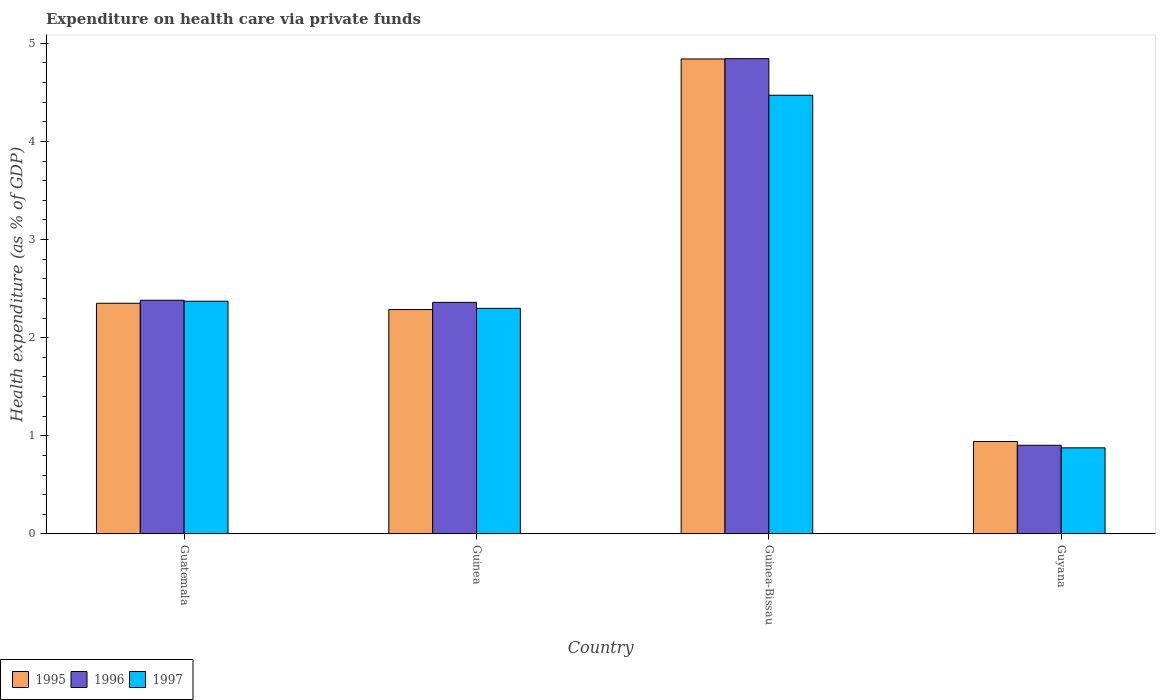How many groups of bars are there?
Your response must be concise. 4. What is the label of the 1st group of bars from the left?
Ensure brevity in your answer.  Guatemala. What is the expenditure made on health care in 1996 in Guatemala?
Your answer should be compact. 2.38. Across all countries, what is the maximum expenditure made on health care in 1995?
Your response must be concise. 4.84. Across all countries, what is the minimum expenditure made on health care in 1996?
Your answer should be compact. 0.9. In which country was the expenditure made on health care in 1995 maximum?
Your answer should be very brief. Guinea-Bissau. In which country was the expenditure made on health care in 1995 minimum?
Keep it short and to the point. Guyana. What is the total expenditure made on health care in 1995 in the graph?
Your response must be concise. 10.42. What is the difference between the expenditure made on health care in 1995 in Guatemala and that in Guinea-Bissau?
Your answer should be compact. -2.49. What is the difference between the expenditure made on health care in 1995 in Guatemala and the expenditure made on health care in 1996 in Guinea-Bissau?
Provide a short and direct response. -2.49. What is the average expenditure made on health care in 1995 per country?
Offer a very short reply. 2.61. What is the difference between the expenditure made on health care of/in 1995 and expenditure made on health care of/in 1997 in Guatemala?
Keep it short and to the point. -0.02. What is the ratio of the expenditure made on health care in 1996 in Guinea to that in Guinea-Bissau?
Offer a terse response. 0.49. Is the expenditure made on health care in 1996 in Guinea less than that in Guyana?
Keep it short and to the point. No. What is the difference between the highest and the second highest expenditure made on health care in 1995?
Offer a very short reply. 0.06. What is the difference between the highest and the lowest expenditure made on health care in 1997?
Offer a terse response. 3.59. In how many countries, is the expenditure made on health care in 1996 greater than the average expenditure made on health care in 1996 taken over all countries?
Provide a succinct answer. 1. What does the 1st bar from the left in Guinea represents?
Your response must be concise. 1995. What does the 2nd bar from the right in Guinea-Bissau represents?
Offer a terse response. 1996. Is it the case that in every country, the sum of the expenditure made on health care in 1997 and expenditure made on health care in 1995 is greater than the expenditure made on health care in 1996?
Make the answer very short. Yes. How many bars are there?
Ensure brevity in your answer.  12. How many countries are there in the graph?
Keep it short and to the point. 4. What is the difference between two consecutive major ticks on the Y-axis?
Keep it short and to the point. 1. Does the graph contain any zero values?
Your answer should be compact. No. Where does the legend appear in the graph?
Keep it short and to the point. Bottom left. How many legend labels are there?
Keep it short and to the point. 3. What is the title of the graph?
Offer a very short reply. Expenditure on health care via private funds. Does "1974" appear as one of the legend labels in the graph?
Keep it short and to the point. No. What is the label or title of the X-axis?
Give a very brief answer. Country. What is the label or title of the Y-axis?
Offer a very short reply. Health expenditure (as % of GDP). What is the Health expenditure (as % of GDP) in 1995 in Guatemala?
Ensure brevity in your answer.  2.35. What is the Health expenditure (as % of GDP) in 1996 in Guatemala?
Ensure brevity in your answer.  2.38. What is the Health expenditure (as % of GDP) of 1997 in Guatemala?
Provide a succinct answer. 2.37. What is the Health expenditure (as % of GDP) of 1995 in Guinea?
Keep it short and to the point. 2.29. What is the Health expenditure (as % of GDP) of 1996 in Guinea?
Your response must be concise. 2.36. What is the Health expenditure (as % of GDP) of 1997 in Guinea?
Provide a short and direct response. 2.3. What is the Health expenditure (as % of GDP) of 1995 in Guinea-Bissau?
Ensure brevity in your answer.  4.84. What is the Health expenditure (as % of GDP) in 1996 in Guinea-Bissau?
Your answer should be very brief. 4.84. What is the Health expenditure (as % of GDP) in 1997 in Guinea-Bissau?
Your answer should be compact. 4.47. What is the Health expenditure (as % of GDP) in 1995 in Guyana?
Offer a very short reply. 0.94. What is the Health expenditure (as % of GDP) in 1996 in Guyana?
Your response must be concise. 0.9. What is the Health expenditure (as % of GDP) in 1997 in Guyana?
Offer a terse response. 0.88. Across all countries, what is the maximum Health expenditure (as % of GDP) of 1995?
Ensure brevity in your answer.  4.84. Across all countries, what is the maximum Health expenditure (as % of GDP) in 1996?
Provide a succinct answer. 4.84. Across all countries, what is the maximum Health expenditure (as % of GDP) of 1997?
Your response must be concise. 4.47. Across all countries, what is the minimum Health expenditure (as % of GDP) of 1995?
Make the answer very short. 0.94. Across all countries, what is the minimum Health expenditure (as % of GDP) in 1996?
Your answer should be very brief. 0.9. Across all countries, what is the minimum Health expenditure (as % of GDP) of 1997?
Provide a short and direct response. 0.88. What is the total Health expenditure (as % of GDP) in 1995 in the graph?
Your answer should be very brief. 10.42. What is the total Health expenditure (as % of GDP) in 1996 in the graph?
Provide a short and direct response. 10.49. What is the total Health expenditure (as % of GDP) in 1997 in the graph?
Give a very brief answer. 10.02. What is the difference between the Health expenditure (as % of GDP) of 1995 in Guatemala and that in Guinea?
Provide a succinct answer. 0.06. What is the difference between the Health expenditure (as % of GDP) of 1996 in Guatemala and that in Guinea?
Your response must be concise. 0.02. What is the difference between the Health expenditure (as % of GDP) in 1997 in Guatemala and that in Guinea?
Make the answer very short. 0.07. What is the difference between the Health expenditure (as % of GDP) in 1995 in Guatemala and that in Guinea-Bissau?
Make the answer very short. -2.49. What is the difference between the Health expenditure (as % of GDP) in 1996 in Guatemala and that in Guinea-Bissau?
Make the answer very short. -2.46. What is the difference between the Health expenditure (as % of GDP) in 1997 in Guatemala and that in Guinea-Bissau?
Offer a very short reply. -2.1. What is the difference between the Health expenditure (as % of GDP) of 1995 in Guatemala and that in Guyana?
Ensure brevity in your answer.  1.41. What is the difference between the Health expenditure (as % of GDP) of 1996 in Guatemala and that in Guyana?
Give a very brief answer. 1.48. What is the difference between the Health expenditure (as % of GDP) of 1997 in Guatemala and that in Guyana?
Keep it short and to the point. 1.49. What is the difference between the Health expenditure (as % of GDP) in 1995 in Guinea and that in Guinea-Bissau?
Ensure brevity in your answer.  -2.55. What is the difference between the Health expenditure (as % of GDP) in 1996 in Guinea and that in Guinea-Bissau?
Give a very brief answer. -2.48. What is the difference between the Health expenditure (as % of GDP) of 1997 in Guinea and that in Guinea-Bissau?
Give a very brief answer. -2.17. What is the difference between the Health expenditure (as % of GDP) of 1995 in Guinea and that in Guyana?
Give a very brief answer. 1.34. What is the difference between the Health expenditure (as % of GDP) in 1996 in Guinea and that in Guyana?
Ensure brevity in your answer.  1.46. What is the difference between the Health expenditure (as % of GDP) in 1997 in Guinea and that in Guyana?
Ensure brevity in your answer.  1.42. What is the difference between the Health expenditure (as % of GDP) in 1995 in Guinea-Bissau and that in Guyana?
Ensure brevity in your answer.  3.9. What is the difference between the Health expenditure (as % of GDP) in 1996 in Guinea-Bissau and that in Guyana?
Make the answer very short. 3.94. What is the difference between the Health expenditure (as % of GDP) of 1997 in Guinea-Bissau and that in Guyana?
Keep it short and to the point. 3.59. What is the difference between the Health expenditure (as % of GDP) in 1995 in Guatemala and the Health expenditure (as % of GDP) in 1996 in Guinea?
Your answer should be very brief. -0.01. What is the difference between the Health expenditure (as % of GDP) of 1995 in Guatemala and the Health expenditure (as % of GDP) of 1997 in Guinea?
Your answer should be compact. 0.05. What is the difference between the Health expenditure (as % of GDP) of 1996 in Guatemala and the Health expenditure (as % of GDP) of 1997 in Guinea?
Your response must be concise. 0.08. What is the difference between the Health expenditure (as % of GDP) in 1995 in Guatemala and the Health expenditure (as % of GDP) in 1996 in Guinea-Bissau?
Provide a short and direct response. -2.49. What is the difference between the Health expenditure (as % of GDP) of 1995 in Guatemala and the Health expenditure (as % of GDP) of 1997 in Guinea-Bissau?
Your answer should be compact. -2.12. What is the difference between the Health expenditure (as % of GDP) of 1996 in Guatemala and the Health expenditure (as % of GDP) of 1997 in Guinea-Bissau?
Give a very brief answer. -2.09. What is the difference between the Health expenditure (as % of GDP) of 1995 in Guatemala and the Health expenditure (as % of GDP) of 1996 in Guyana?
Your response must be concise. 1.45. What is the difference between the Health expenditure (as % of GDP) in 1995 in Guatemala and the Health expenditure (as % of GDP) in 1997 in Guyana?
Keep it short and to the point. 1.47. What is the difference between the Health expenditure (as % of GDP) of 1996 in Guatemala and the Health expenditure (as % of GDP) of 1997 in Guyana?
Your answer should be compact. 1.5. What is the difference between the Health expenditure (as % of GDP) of 1995 in Guinea and the Health expenditure (as % of GDP) of 1996 in Guinea-Bissau?
Provide a succinct answer. -2.56. What is the difference between the Health expenditure (as % of GDP) of 1995 in Guinea and the Health expenditure (as % of GDP) of 1997 in Guinea-Bissau?
Give a very brief answer. -2.18. What is the difference between the Health expenditure (as % of GDP) in 1996 in Guinea and the Health expenditure (as % of GDP) in 1997 in Guinea-Bissau?
Make the answer very short. -2.11. What is the difference between the Health expenditure (as % of GDP) in 1995 in Guinea and the Health expenditure (as % of GDP) in 1996 in Guyana?
Offer a terse response. 1.38. What is the difference between the Health expenditure (as % of GDP) in 1995 in Guinea and the Health expenditure (as % of GDP) in 1997 in Guyana?
Give a very brief answer. 1.41. What is the difference between the Health expenditure (as % of GDP) in 1996 in Guinea and the Health expenditure (as % of GDP) in 1997 in Guyana?
Make the answer very short. 1.48. What is the difference between the Health expenditure (as % of GDP) in 1995 in Guinea-Bissau and the Health expenditure (as % of GDP) in 1996 in Guyana?
Your answer should be very brief. 3.94. What is the difference between the Health expenditure (as % of GDP) of 1995 in Guinea-Bissau and the Health expenditure (as % of GDP) of 1997 in Guyana?
Your response must be concise. 3.96. What is the difference between the Health expenditure (as % of GDP) of 1996 in Guinea-Bissau and the Health expenditure (as % of GDP) of 1997 in Guyana?
Your answer should be very brief. 3.97. What is the average Health expenditure (as % of GDP) of 1995 per country?
Make the answer very short. 2.6. What is the average Health expenditure (as % of GDP) in 1996 per country?
Keep it short and to the point. 2.62. What is the average Health expenditure (as % of GDP) of 1997 per country?
Keep it short and to the point. 2.5. What is the difference between the Health expenditure (as % of GDP) of 1995 and Health expenditure (as % of GDP) of 1996 in Guatemala?
Your answer should be very brief. -0.03. What is the difference between the Health expenditure (as % of GDP) of 1995 and Health expenditure (as % of GDP) of 1997 in Guatemala?
Provide a succinct answer. -0.02. What is the difference between the Health expenditure (as % of GDP) of 1996 and Health expenditure (as % of GDP) of 1997 in Guatemala?
Keep it short and to the point. 0.01. What is the difference between the Health expenditure (as % of GDP) of 1995 and Health expenditure (as % of GDP) of 1996 in Guinea?
Offer a terse response. -0.07. What is the difference between the Health expenditure (as % of GDP) in 1995 and Health expenditure (as % of GDP) in 1997 in Guinea?
Provide a short and direct response. -0.01. What is the difference between the Health expenditure (as % of GDP) in 1996 and Health expenditure (as % of GDP) in 1997 in Guinea?
Your answer should be very brief. 0.06. What is the difference between the Health expenditure (as % of GDP) of 1995 and Health expenditure (as % of GDP) of 1996 in Guinea-Bissau?
Your response must be concise. -0. What is the difference between the Health expenditure (as % of GDP) of 1995 and Health expenditure (as % of GDP) of 1997 in Guinea-Bissau?
Offer a very short reply. 0.37. What is the difference between the Health expenditure (as % of GDP) of 1996 and Health expenditure (as % of GDP) of 1997 in Guinea-Bissau?
Ensure brevity in your answer.  0.37. What is the difference between the Health expenditure (as % of GDP) in 1995 and Health expenditure (as % of GDP) in 1996 in Guyana?
Give a very brief answer. 0.04. What is the difference between the Health expenditure (as % of GDP) in 1995 and Health expenditure (as % of GDP) in 1997 in Guyana?
Give a very brief answer. 0.06. What is the difference between the Health expenditure (as % of GDP) of 1996 and Health expenditure (as % of GDP) of 1997 in Guyana?
Give a very brief answer. 0.03. What is the ratio of the Health expenditure (as % of GDP) of 1995 in Guatemala to that in Guinea?
Ensure brevity in your answer.  1.03. What is the ratio of the Health expenditure (as % of GDP) of 1996 in Guatemala to that in Guinea?
Offer a terse response. 1.01. What is the ratio of the Health expenditure (as % of GDP) of 1997 in Guatemala to that in Guinea?
Your answer should be compact. 1.03. What is the ratio of the Health expenditure (as % of GDP) of 1995 in Guatemala to that in Guinea-Bissau?
Your response must be concise. 0.49. What is the ratio of the Health expenditure (as % of GDP) in 1996 in Guatemala to that in Guinea-Bissau?
Keep it short and to the point. 0.49. What is the ratio of the Health expenditure (as % of GDP) of 1997 in Guatemala to that in Guinea-Bissau?
Give a very brief answer. 0.53. What is the ratio of the Health expenditure (as % of GDP) in 1995 in Guatemala to that in Guyana?
Offer a very short reply. 2.49. What is the ratio of the Health expenditure (as % of GDP) in 1996 in Guatemala to that in Guyana?
Ensure brevity in your answer.  2.63. What is the ratio of the Health expenditure (as % of GDP) of 1997 in Guatemala to that in Guyana?
Keep it short and to the point. 2.7. What is the ratio of the Health expenditure (as % of GDP) of 1995 in Guinea to that in Guinea-Bissau?
Offer a very short reply. 0.47. What is the ratio of the Health expenditure (as % of GDP) of 1996 in Guinea to that in Guinea-Bissau?
Your answer should be compact. 0.49. What is the ratio of the Health expenditure (as % of GDP) of 1997 in Guinea to that in Guinea-Bissau?
Give a very brief answer. 0.51. What is the ratio of the Health expenditure (as % of GDP) of 1995 in Guinea to that in Guyana?
Make the answer very short. 2.43. What is the ratio of the Health expenditure (as % of GDP) in 1996 in Guinea to that in Guyana?
Provide a succinct answer. 2.61. What is the ratio of the Health expenditure (as % of GDP) in 1997 in Guinea to that in Guyana?
Keep it short and to the point. 2.62. What is the ratio of the Health expenditure (as % of GDP) of 1995 in Guinea-Bissau to that in Guyana?
Your answer should be compact. 5.14. What is the ratio of the Health expenditure (as % of GDP) of 1996 in Guinea-Bissau to that in Guyana?
Keep it short and to the point. 5.36. What is the ratio of the Health expenditure (as % of GDP) in 1997 in Guinea-Bissau to that in Guyana?
Make the answer very short. 5.09. What is the difference between the highest and the second highest Health expenditure (as % of GDP) in 1995?
Offer a terse response. 2.49. What is the difference between the highest and the second highest Health expenditure (as % of GDP) in 1996?
Provide a short and direct response. 2.46. What is the difference between the highest and the second highest Health expenditure (as % of GDP) in 1997?
Provide a short and direct response. 2.1. What is the difference between the highest and the lowest Health expenditure (as % of GDP) in 1995?
Make the answer very short. 3.9. What is the difference between the highest and the lowest Health expenditure (as % of GDP) in 1996?
Ensure brevity in your answer.  3.94. What is the difference between the highest and the lowest Health expenditure (as % of GDP) in 1997?
Give a very brief answer. 3.59. 